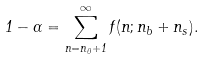<formula> <loc_0><loc_0><loc_500><loc_500>1 - \alpha = \sum ^ { \infty } _ { n = n _ { 0 } + 1 } f ( n ; n _ { b } + n _ { s } ) .</formula> 